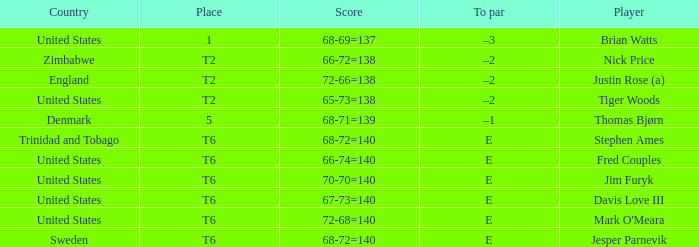What was the TO par for the player who scored 68-71=139? –1. 